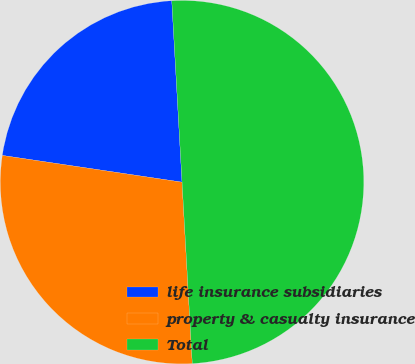<chart> <loc_0><loc_0><loc_500><loc_500><pie_chart><fcel>life insurance subsidiaries<fcel>property & casualty insurance<fcel>Total<nl><fcel>21.75%<fcel>28.25%<fcel>50.0%<nl></chart> 